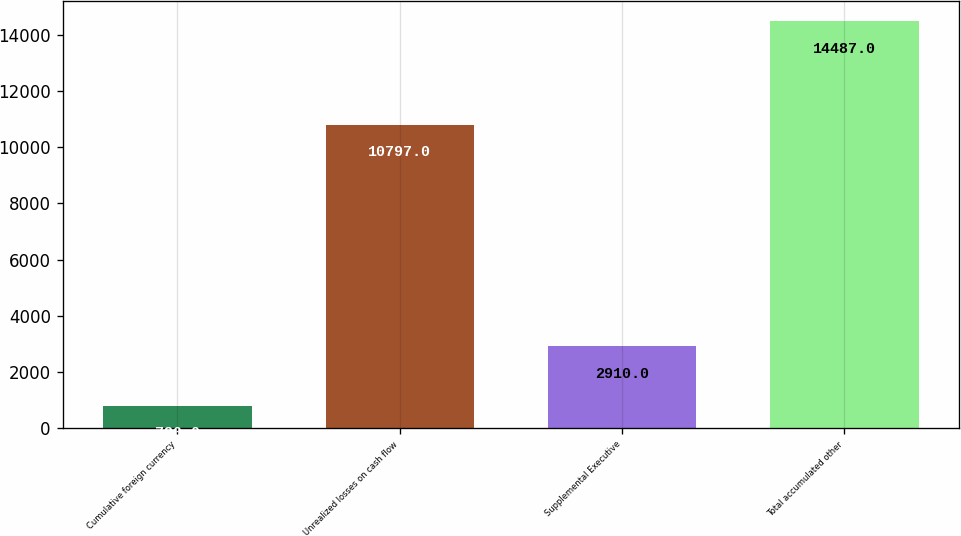Convert chart to OTSL. <chart><loc_0><loc_0><loc_500><loc_500><bar_chart><fcel>Cumulative foreign currency<fcel>Unrealized losses on cash flow<fcel>Supplemental Executive<fcel>Total accumulated other<nl><fcel>780<fcel>10797<fcel>2910<fcel>14487<nl></chart> 